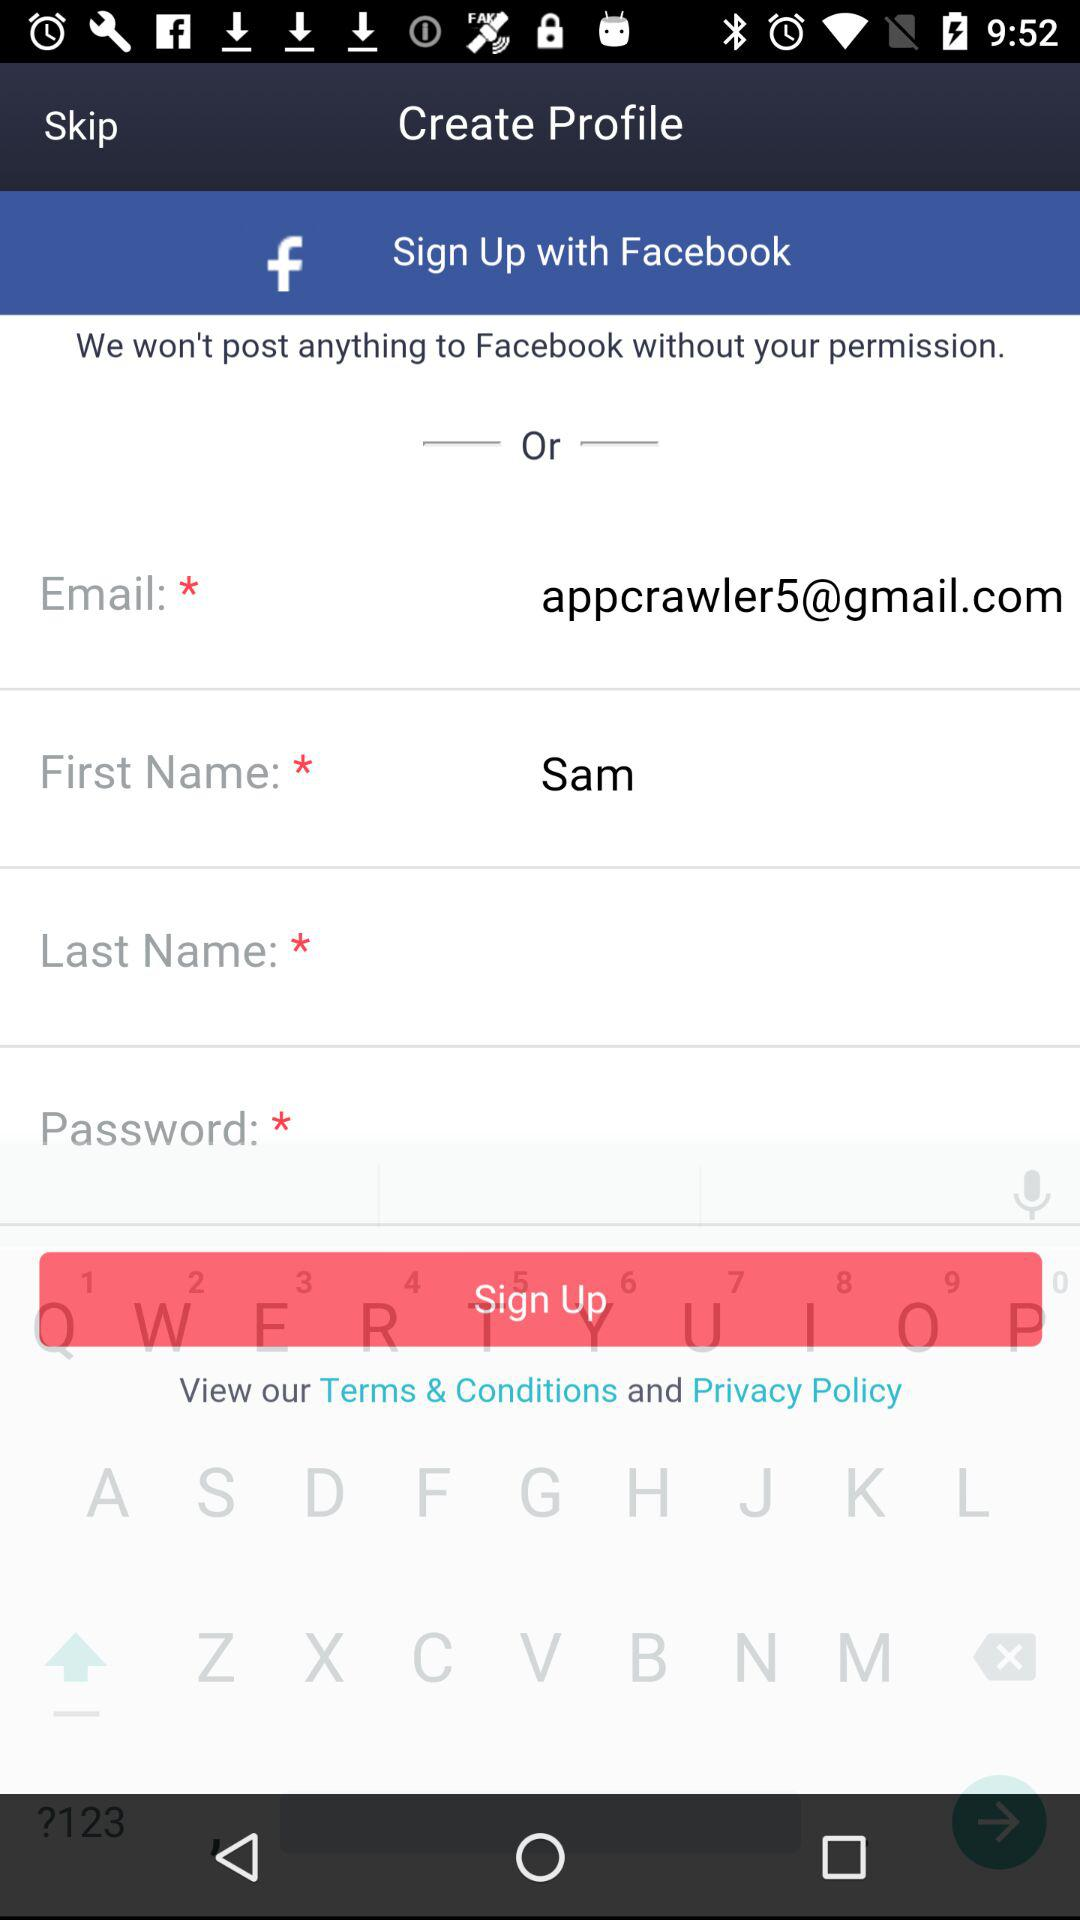What are the different options through which we can sign up? The different options through which you can sign up are "Facebook" and "Email". 